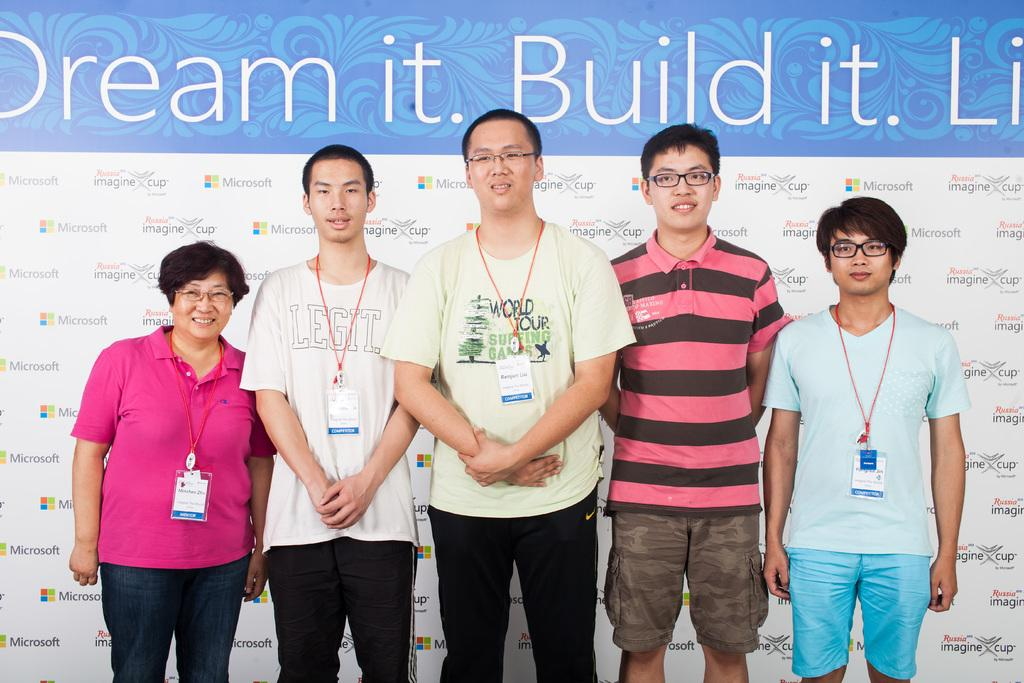What is happening in the center of the image? There are people standing in the center of the image. What can be observed about the people in the image? The people are wearing ID cards. What is visible in the background of the image? There is a banner with text in the background of the image. What type of trouble is the person in the bedroom experiencing in the image? There is no bedroom or person experiencing trouble in the image; it features people standing with ID cards and a banner in the background. 